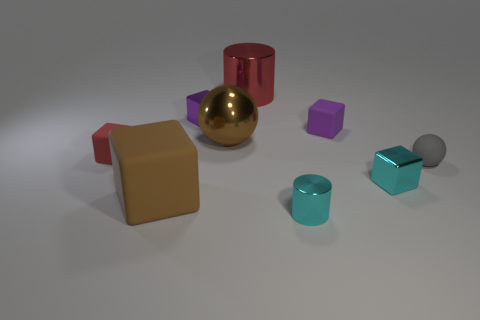Subtract all red rubber blocks. How many blocks are left? 4 Subtract all red blocks. How many blocks are left? 4 Subtract all blue blocks. Subtract all red spheres. How many blocks are left? 5 Add 1 tiny red objects. How many objects exist? 10 Subtract all spheres. How many objects are left? 7 Add 4 brown blocks. How many brown blocks exist? 5 Subtract 0 yellow balls. How many objects are left? 9 Subtract all large green matte cubes. Subtract all small red rubber objects. How many objects are left? 8 Add 5 red blocks. How many red blocks are left? 6 